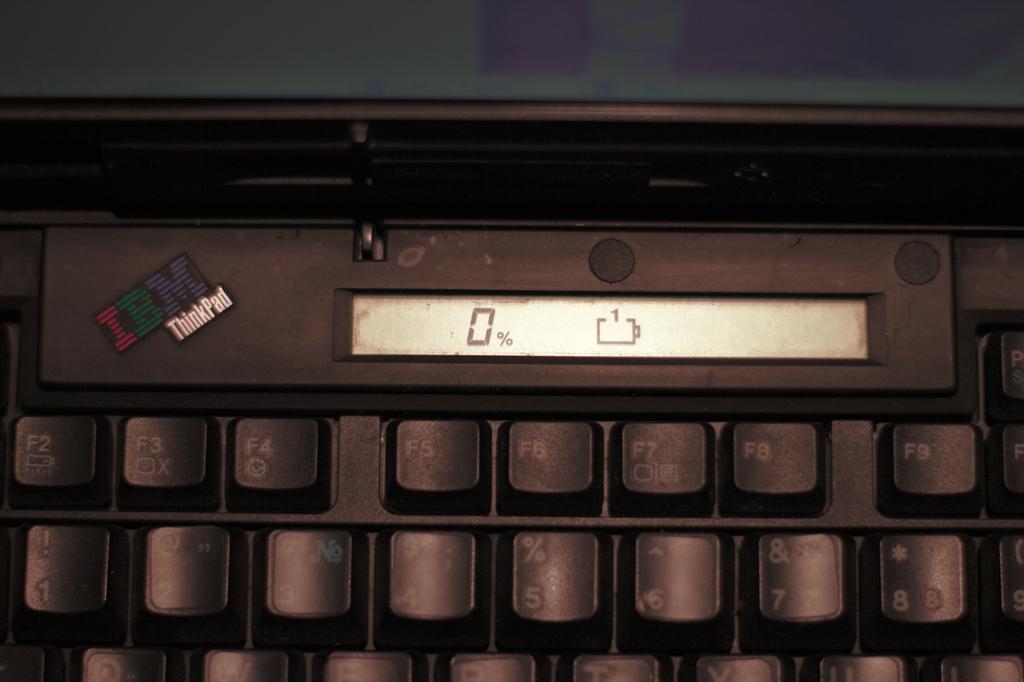What is the brand of laptop?
Ensure brevity in your answer.  Ibm. What percentage is it at?
Provide a short and direct response. 0. 